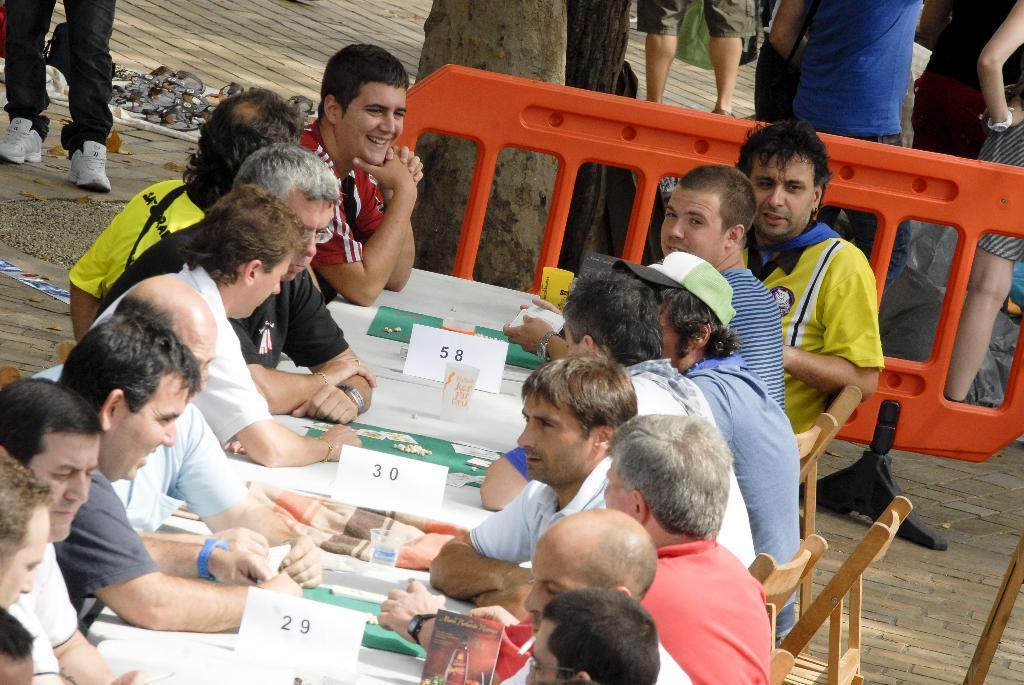Could you give a brief overview of what you see in this image? In the middle of the image few people are sitting on chairs and there is a table, on the table there are some papers and glasses. Behind them there is a fencing. At the top of the image there is a tree and few people are standing and there are some foot wear. 